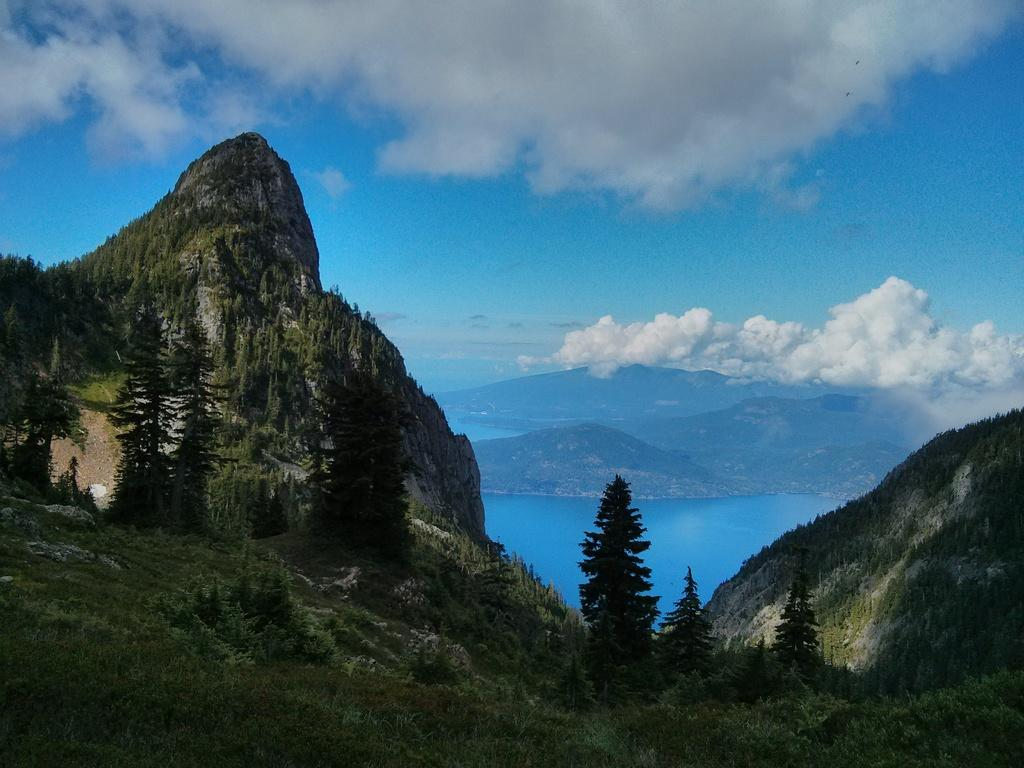What type of vegetation can be seen in the image? There is grass, plants, and trees visible in the image. What natural element is present in the image besides vegetation? There is water visible in the image. What geographical feature can be seen in the image? There is a mountain in the image. What is visible in the background of the image? The sky is visible in the background of the image. What is the weather like in the image? The sky has heavy clouds, suggesting a potentially stormy or overcast day. How many feet are visible in the image? There are no feet present in the image; it primarily features natural elements such as vegetation, water, and a mountain. 